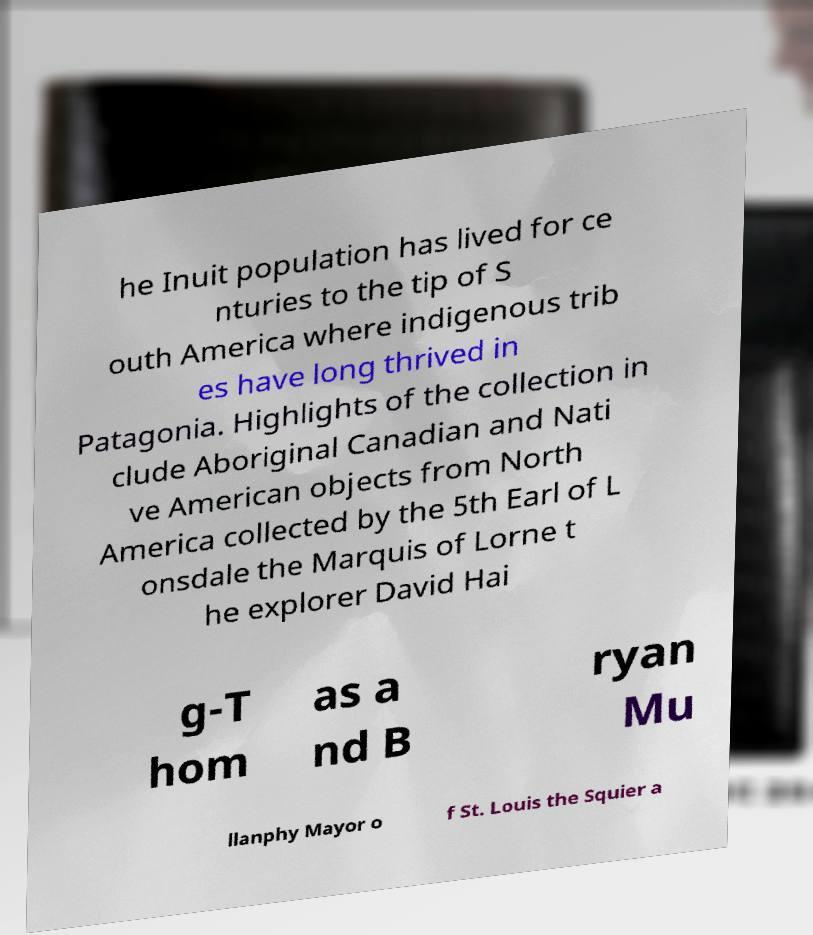Please read and relay the text visible in this image. What does it say? he Inuit population has lived for ce nturies to the tip of S outh America where indigenous trib es have long thrived in Patagonia. Highlights of the collection in clude Aboriginal Canadian and Nati ve American objects from North America collected by the 5th Earl of L onsdale the Marquis of Lorne t he explorer David Hai g-T hom as a nd B ryan Mu llanphy Mayor o f St. Louis the Squier a 